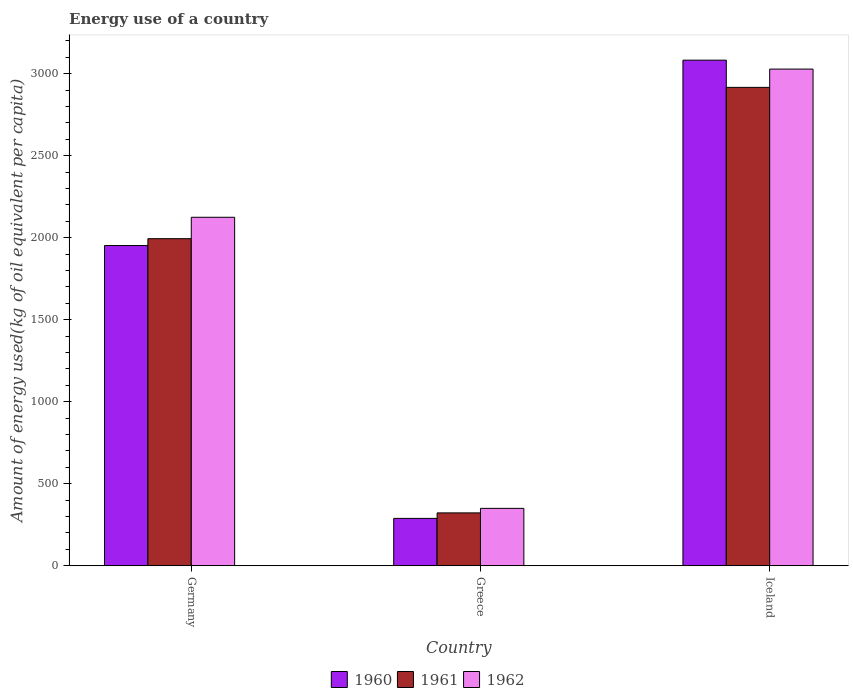How many different coloured bars are there?
Keep it short and to the point. 3. Are the number of bars on each tick of the X-axis equal?
Your answer should be compact. Yes. How many bars are there on the 1st tick from the right?
Offer a very short reply. 3. In how many cases, is the number of bars for a given country not equal to the number of legend labels?
Give a very brief answer. 0. What is the amount of energy used in in 1962 in Greece?
Give a very brief answer. 350.1. Across all countries, what is the maximum amount of energy used in in 1960?
Make the answer very short. 3082.71. Across all countries, what is the minimum amount of energy used in in 1960?
Offer a very short reply. 289.06. In which country was the amount of energy used in in 1961 maximum?
Your response must be concise. Iceland. In which country was the amount of energy used in in 1961 minimum?
Offer a terse response. Greece. What is the total amount of energy used in in 1960 in the graph?
Offer a very short reply. 5324.36. What is the difference between the amount of energy used in in 1961 in Greece and that in Iceland?
Ensure brevity in your answer.  -2594.22. What is the difference between the amount of energy used in in 1962 in Greece and the amount of energy used in in 1960 in Iceland?
Ensure brevity in your answer.  -2732.61. What is the average amount of energy used in in 1962 per country?
Give a very brief answer. 1834.42. What is the difference between the amount of energy used in of/in 1961 and amount of energy used in of/in 1960 in Greece?
Offer a very short reply. 33.43. What is the ratio of the amount of energy used in in 1962 in Germany to that in Iceland?
Your answer should be very brief. 0.7. Is the amount of energy used in in 1962 in Germany less than that in Greece?
Give a very brief answer. No. Is the difference between the amount of energy used in in 1961 in Germany and Iceland greater than the difference between the amount of energy used in in 1960 in Germany and Iceland?
Give a very brief answer. Yes. What is the difference between the highest and the second highest amount of energy used in in 1961?
Provide a succinct answer. -922.38. What is the difference between the highest and the lowest amount of energy used in in 1961?
Offer a very short reply. 2594.22. What does the 2nd bar from the left in Germany represents?
Your answer should be compact. 1961. What does the 2nd bar from the right in Greece represents?
Your answer should be compact. 1961. How many bars are there?
Give a very brief answer. 9. What is the difference between two consecutive major ticks on the Y-axis?
Your answer should be compact. 500. Are the values on the major ticks of Y-axis written in scientific E-notation?
Provide a short and direct response. No. Does the graph contain any zero values?
Ensure brevity in your answer.  No. How many legend labels are there?
Offer a very short reply. 3. What is the title of the graph?
Your answer should be very brief. Energy use of a country. What is the label or title of the X-axis?
Offer a very short reply. Country. What is the label or title of the Y-axis?
Your response must be concise. Amount of energy used(kg of oil equivalent per capita). What is the Amount of energy used(kg of oil equivalent per capita) of 1960 in Germany?
Offer a terse response. 1952.59. What is the Amount of energy used(kg of oil equivalent per capita) in 1961 in Germany?
Provide a short and direct response. 1994.32. What is the Amount of energy used(kg of oil equivalent per capita) of 1962 in Germany?
Your answer should be compact. 2124.85. What is the Amount of energy used(kg of oil equivalent per capita) of 1960 in Greece?
Keep it short and to the point. 289.06. What is the Amount of energy used(kg of oil equivalent per capita) of 1961 in Greece?
Make the answer very short. 322.49. What is the Amount of energy used(kg of oil equivalent per capita) of 1962 in Greece?
Give a very brief answer. 350.1. What is the Amount of energy used(kg of oil equivalent per capita) in 1960 in Iceland?
Offer a very short reply. 3082.71. What is the Amount of energy used(kg of oil equivalent per capita) in 1961 in Iceland?
Make the answer very short. 2916.71. What is the Amount of energy used(kg of oil equivalent per capita) of 1962 in Iceland?
Offer a very short reply. 3028.3. Across all countries, what is the maximum Amount of energy used(kg of oil equivalent per capita) in 1960?
Make the answer very short. 3082.71. Across all countries, what is the maximum Amount of energy used(kg of oil equivalent per capita) in 1961?
Your response must be concise. 2916.71. Across all countries, what is the maximum Amount of energy used(kg of oil equivalent per capita) in 1962?
Give a very brief answer. 3028.3. Across all countries, what is the minimum Amount of energy used(kg of oil equivalent per capita) of 1960?
Keep it short and to the point. 289.06. Across all countries, what is the minimum Amount of energy used(kg of oil equivalent per capita) of 1961?
Keep it short and to the point. 322.49. Across all countries, what is the minimum Amount of energy used(kg of oil equivalent per capita) in 1962?
Keep it short and to the point. 350.1. What is the total Amount of energy used(kg of oil equivalent per capita) in 1960 in the graph?
Provide a succinct answer. 5324.36. What is the total Amount of energy used(kg of oil equivalent per capita) in 1961 in the graph?
Give a very brief answer. 5233.52. What is the total Amount of energy used(kg of oil equivalent per capita) in 1962 in the graph?
Your response must be concise. 5503.25. What is the difference between the Amount of energy used(kg of oil equivalent per capita) of 1960 in Germany and that in Greece?
Your answer should be very brief. 1663.53. What is the difference between the Amount of energy used(kg of oil equivalent per capita) in 1961 in Germany and that in Greece?
Provide a succinct answer. 1671.83. What is the difference between the Amount of energy used(kg of oil equivalent per capita) of 1962 in Germany and that in Greece?
Your response must be concise. 1774.75. What is the difference between the Amount of energy used(kg of oil equivalent per capita) in 1960 in Germany and that in Iceland?
Ensure brevity in your answer.  -1130.12. What is the difference between the Amount of energy used(kg of oil equivalent per capita) of 1961 in Germany and that in Iceland?
Your response must be concise. -922.38. What is the difference between the Amount of energy used(kg of oil equivalent per capita) of 1962 in Germany and that in Iceland?
Ensure brevity in your answer.  -903.45. What is the difference between the Amount of energy used(kg of oil equivalent per capita) in 1960 in Greece and that in Iceland?
Give a very brief answer. -2793.65. What is the difference between the Amount of energy used(kg of oil equivalent per capita) of 1961 in Greece and that in Iceland?
Provide a short and direct response. -2594.22. What is the difference between the Amount of energy used(kg of oil equivalent per capita) in 1962 in Greece and that in Iceland?
Provide a short and direct response. -2678.2. What is the difference between the Amount of energy used(kg of oil equivalent per capita) of 1960 in Germany and the Amount of energy used(kg of oil equivalent per capita) of 1961 in Greece?
Give a very brief answer. 1630.1. What is the difference between the Amount of energy used(kg of oil equivalent per capita) of 1960 in Germany and the Amount of energy used(kg of oil equivalent per capita) of 1962 in Greece?
Ensure brevity in your answer.  1602.49. What is the difference between the Amount of energy used(kg of oil equivalent per capita) of 1961 in Germany and the Amount of energy used(kg of oil equivalent per capita) of 1962 in Greece?
Give a very brief answer. 1644.22. What is the difference between the Amount of energy used(kg of oil equivalent per capita) in 1960 in Germany and the Amount of energy used(kg of oil equivalent per capita) in 1961 in Iceland?
Your answer should be very brief. -964.12. What is the difference between the Amount of energy used(kg of oil equivalent per capita) of 1960 in Germany and the Amount of energy used(kg of oil equivalent per capita) of 1962 in Iceland?
Offer a terse response. -1075.71. What is the difference between the Amount of energy used(kg of oil equivalent per capita) in 1961 in Germany and the Amount of energy used(kg of oil equivalent per capita) in 1962 in Iceland?
Provide a succinct answer. -1033.97. What is the difference between the Amount of energy used(kg of oil equivalent per capita) of 1960 in Greece and the Amount of energy used(kg of oil equivalent per capita) of 1961 in Iceland?
Your answer should be compact. -2627.65. What is the difference between the Amount of energy used(kg of oil equivalent per capita) of 1960 in Greece and the Amount of energy used(kg of oil equivalent per capita) of 1962 in Iceland?
Provide a succinct answer. -2739.24. What is the difference between the Amount of energy used(kg of oil equivalent per capita) in 1961 in Greece and the Amount of energy used(kg of oil equivalent per capita) in 1962 in Iceland?
Offer a very short reply. -2705.81. What is the average Amount of energy used(kg of oil equivalent per capita) in 1960 per country?
Give a very brief answer. 1774.79. What is the average Amount of energy used(kg of oil equivalent per capita) of 1961 per country?
Offer a very short reply. 1744.51. What is the average Amount of energy used(kg of oil equivalent per capita) in 1962 per country?
Keep it short and to the point. 1834.42. What is the difference between the Amount of energy used(kg of oil equivalent per capita) of 1960 and Amount of energy used(kg of oil equivalent per capita) of 1961 in Germany?
Your response must be concise. -41.74. What is the difference between the Amount of energy used(kg of oil equivalent per capita) in 1960 and Amount of energy used(kg of oil equivalent per capita) in 1962 in Germany?
Provide a short and direct response. -172.26. What is the difference between the Amount of energy used(kg of oil equivalent per capita) in 1961 and Amount of energy used(kg of oil equivalent per capita) in 1962 in Germany?
Make the answer very short. -130.52. What is the difference between the Amount of energy used(kg of oil equivalent per capita) in 1960 and Amount of energy used(kg of oil equivalent per capita) in 1961 in Greece?
Offer a very short reply. -33.43. What is the difference between the Amount of energy used(kg of oil equivalent per capita) of 1960 and Amount of energy used(kg of oil equivalent per capita) of 1962 in Greece?
Keep it short and to the point. -61.04. What is the difference between the Amount of energy used(kg of oil equivalent per capita) of 1961 and Amount of energy used(kg of oil equivalent per capita) of 1962 in Greece?
Offer a terse response. -27.61. What is the difference between the Amount of energy used(kg of oil equivalent per capita) in 1960 and Amount of energy used(kg of oil equivalent per capita) in 1961 in Iceland?
Provide a succinct answer. 166.01. What is the difference between the Amount of energy used(kg of oil equivalent per capita) of 1960 and Amount of energy used(kg of oil equivalent per capita) of 1962 in Iceland?
Keep it short and to the point. 54.41. What is the difference between the Amount of energy used(kg of oil equivalent per capita) of 1961 and Amount of energy used(kg of oil equivalent per capita) of 1962 in Iceland?
Offer a terse response. -111.59. What is the ratio of the Amount of energy used(kg of oil equivalent per capita) of 1960 in Germany to that in Greece?
Make the answer very short. 6.75. What is the ratio of the Amount of energy used(kg of oil equivalent per capita) in 1961 in Germany to that in Greece?
Your answer should be very brief. 6.18. What is the ratio of the Amount of energy used(kg of oil equivalent per capita) of 1962 in Germany to that in Greece?
Offer a very short reply. 6.07. What is the ratio of the Amount of energy used(kg of oil equivalent per capita) in 1960 in Germany to that in Iceland?
Your answer should be very brief. 0.63. What is the ratio of the Amount of energy used(kg of oil equivalent per capita) in 1961 in Germany to that in Iceland?
Ensure brevity in your answer.  0.68. What is the ratio of the Amount of energy used(kg of oil equivalent per capita) in 1962 in Germany to that in Iceland?
Offer a very short reply. 0.7. What is the ratio of the Amount of energy used(kg of oil equivalent per capita) of 1960 in Greece to that in Iceland?
Provide a succinct answer. 0.09. What is the ratio of the Amount of energy used(kg of oil equivalent per capita) of 1961 in Greece to that in Iceland?
Your answer should be very brief. 0.11. What is the ratio of the Amount of energy used(kg of oil equivalent per capita) of 1962 in Greece to that in Iceland?
Ensure brevity in your answer.  0.12. What is the difference between the highest and the second highest Amount of energy used(kg of oil equivalent per capita) of 1960?
Make the answer very short. 1130.12. What is the difference between the highest and the second highest Amount of energy used(kg of oil equivalent per capita) of 1961?
Provide a short and direct response. 922.38. What is the difference between the highest and the second highest Amount of energy used(kg of oil equivalent per capita) in 1962?
Provide a short and direct response. 903.45. What is the difference between the highest and the lowest Amount of energy used(kg of oil equivalent per capita) in 1960?
Ensure brevity in your answer.  2793.65. What is the difference between the highest and the lowest Amount of energy used(kg of oil equivalent per capita) in 1961?
Ensure brevity in your answer.  2594.22. What is the difference between the highest and the lowest Amount of energy used(kg of oil equivalent per capita) in 1962?
Keep it short and to the point. 2678.2. 